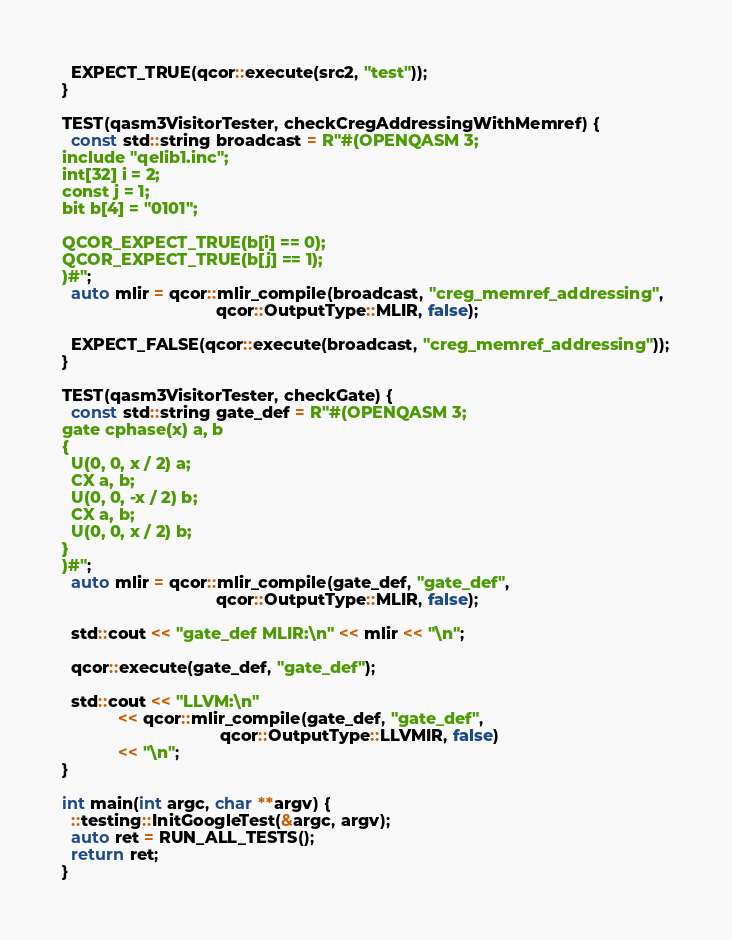Convert code to text. <code><loc_0><loc_0><loc_500><loc_500><_C++_>  EXPECT_TRUE(qcor::execute(src2, "test"));
}

TEST(qasm3VisitorTester, checkCregAddressingWithMemref) {
  const std::string broadcast = R"#(OPENQASM 3;
include "qelib1.inc";
int[32] i = 2;
const j = 1;
bit b[4] = "0101";

QCOR_EXPECT_TRUE(b[i] == 0);
QCOR_EXPECT_TRUE(b[j] == 1);
)#";
  auto mlir = qcor::mlir_compile(broadcast, "creg_memref_addressing",
                                 qcor::OutputType::MLIR, false);

  EXPECT_FALSE(qcor::execute(broadcast, "creg_memref_addressing"));
}

TEST(qasm3VisitorTester, checkGate) {
  const std::string gate_def = R"#(OPENQASM 3;
gate cphase(x) a, b
{
  U(0, 0, x / 2) a;
  CX a, b;
  U(0, 0, -x / 2) b;
  CX a, b;
  U(0, 0, x / 2) b;
}
)#";
  auto mlir = qcor::mlir_compile(gate_def, "gate_def",
                                 qcor::OutputType::MLIR, false);

  std::cout << "gate_def MLIR:\n" << mlir << "\n";

  qcor::execute(gate_def, "gate_def");

  std::cout << "LLVM:\n"
            << qcor::mlir_compile(gate_def, "gate_def",
                                  qcor::OutputType::LLVMIR, false)
            << "\n";
}

int main(int argc, char **argv) {
  ::testing::InitGoogleTest(&argc, argv);
  auto ret = RUN_ALL_TESTS();
  return ret;
}</code> 